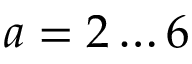Convert formula to latex. <formula><loc_0><loc_0><loc_500><loc_500>a = 2 \dots 6</formula> 